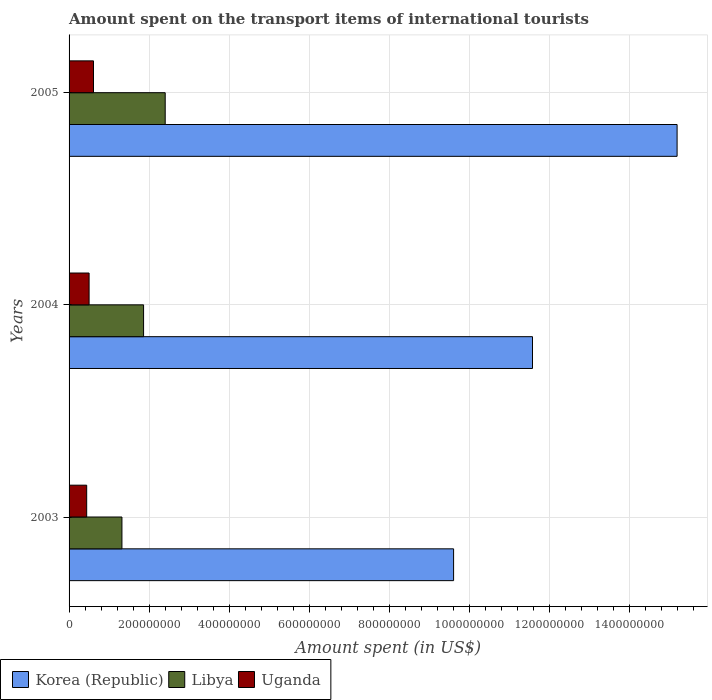How many different coloured bars are there?
Offer a terse response. 3. How many groups of bars are there?
Make the answer very short. 3. Are the number of bars per tick equal to the number of legend labels?
Give a very brief answer. Yes. In how many cases, is the number of bars for a given year not equal to the number of legend labels?
Offer a terse response. 0. Across all years, what is the maximum amount spent on the transport items of international tourists in Libya?
Offer a terse response. 2.40e+08. Across all years, what is the minimum amount spent on the transport items of international tourists in Uganda?
Make the answer very short. 4.40e+07. In which year was the amount spent on the transport items of international tourists in Uganda maximum?
Provide a succinct answer. 2005. In which year was the amount spent on the transport items of international tourists in Libya minimum?
Ensure brevity in your answer.  2003. What is the total amount spent on the transport items of international tourists in Korea (Republic) in the graph?
Your response must be concise. 3.64e+09. What is the difference between the amount spent on the transport items of international tourists in Korea (Republic) in 2003 and that in 2004?
Provide a short and direct response. -1.97e+08. What is the difference between the amount spent on the transport items of international tourists in Libya in 2004 and the amount spent on the transport items of international tourists in Uganda in 2003?
Offer a very short reply. 1.42e+08. What is the average amount spent on the transport items of international tourists in Libya per year?
Make the answer very short. 1.86e+08. In the year 2003, what is the difference between the amount spent on the transport items of international tourists in Libya and amount spent on the transport items of international tourists in Uganda?
Your response must be concise. 8.80e+07. What is the ratio of the amount spent on the transport items of international tourists in Uganda in 2004 to that in 2005?
Ensure brevity in your answer.  0.82. What is the difference between the highest and the second highest amount spent on the transport items of international tourists in Uganda?
Your response must be concise. 1.10e+07. What is the difference between the highest and the lowest amount spent on the transport items of international tourists in Uganda?
Make the answer very short. 1.70e+07. Is the sum of the amount spent on the transport items of international tourists in Korea (Republic) in 2003 and 2004 greater than the maximum amount spent on the transport items of international tourists in Libya across all years?
Give a very brief answer. Yes. What does the 1st bar from the top in 2003 represents?
Your answer should be very brief. Uganda. Is it the case that in every year, the sum of the amount spent on the transport items of international tourists in Uganda and amount spent on the transport items of international tourists in Libya is greater than the amount spent on the transport items of international tourists in Korea (Republic)?
Offer a terse response. No. Does the graph contain grids?
Offer a terse response. Yes. Where does the legend appear in the graph?
Offer a terse response. Bottom left. How many legend labels are there?
Offer a terse response. 3. How are the legend labels stacked?
Make the answer very short. Horizontal. What is the title of the graph?
Your response must be concise. Amount spent on the transport items of international tourists. What is the label or title of the X-axis?
Provide a succinct answer. Amount spent (in US$). What is the label or title of the Y-axis?
Your response must be concise. Years. What is the Amount spent (in US$) in Korea (Republic) in 2003?
Give a very brief answer. 9.60e+08. What is the Amount spent (in US$) in Libya in 2003?
Keep it short and to the point. 1.32e+08. What is the Amount spent (in US$) in Uganda in 2003?
Your answer should be very brief. 4.40e+07. What is the Amount spent (in US$) of Korea (Republic) in 2004?
Give a very brief answer. 1.16e+09. What is the Amount spent (in US$) of Libya in 2004?
Ensure brevity in your answer.  1.86e+08. What is the Amount spent (in US$) of Uganda in 2004?
Offer a terse response. 5.00e+07. What is the Amount spent (in US$) of Korea (Republic) in 2005?
Offer a very short reply. 1.52e+09. What is the Amount spent (in US$) of Libya in 2005?
Your response must be concise. 2.40e+08. What is the Amount spent (in US$) in Uganda in 2005?
Your answer should be compact. 6.10e+07. Across all years, what is the maximum Amount spent (in US$) in Korea (Republic)?
Provide a short and direct response. 1.52e+09. Across all years, what is the maximum Amount spent (in US$) in Libya?
Provide a succinct answer. 2.40e+08. Across all years, what is the maximum Amount spent (in US$) in Uganda?
Provide a succinct answer. 6.10e+07. Across all years, what is the minimum Amount spent (in US$) of Korea (Republic)?
Your answer should be compact. 9.60e+08. Across all years, what is the minimum Amount spent (in US$) of Libya?
Keep it short and to the point. 1.32e+08. Across all years, what is the minimum Amount spent (in US$) in Uganda?
Ensure brevity in your answer.  4.40e+07. What is the total Amount spent (in US$) of Korea (Republic) in the graph?
Make the answer very short. 3.64e+09. What is the total Amount spent (in US$) of Libya in the graph?
Provide a succinct answer. 5.58e+08. What is the total Amount spent (in US$) in Uganda in the graph?
Offer a very short reply. 1.55e+08. What is the difference between the Amount spent (in US$) of Korea (Republic) in 2003 and that in 2004?
Your answer should be very brief. -1.97e+08. What is the difference between the Amount spent (in US$) of Libya in 2003 and that in 2004?
Give a very brief answer. -5.40e+07. What is the difference between the Amount spent (in US$) in Uganda in 2003 and that in 2004?
Offer a terse response. -6.00e+06. What is the difference between the Amount spent (in US$) of Korea (Republic) in 2003 and that in 2005?
Provide a short and direct response. -5.58e+08. What is the difference between the Amount spent (in US$) of Libya in 2003 and that in 2005?
Offer a very short reply. -1.08e+08. What is the difference between the Amount spent (in US$) in Uganda in 2003 and that in 2005?
Give a very brief answer. -1.70e+07. What is the difference between the Amount spent (in US$) in Korea (Republic) in 2004 and that in 2005?
Your answer should be very brief. -3.61e+08. What is the difference between the Amount spent (in US$) in Libya in 2004 and that in 2005?
Your answer should be compact. -5.40e+07. What is the difference between the Amount spent (in US$) of Uganda in 2004 and that in 2005?
Offer a very short reply. -1.10e+07. What is the difference between the Amount spent (in US$) in Korea (Republic) in 2003 and the Amount spent (in US$) in Libya in 2004?
Your response must be concise. 7.74e+08. What is the difference between the Amount spent (in US$) of Korea (Republic) in 2003 and the Amount spent (in US$) of Uganda in 2004?
Make the answer very short. 9.10e+08. What is the difference between the Amount spent (in US$) in Libya in 2003 and the Amount spent (in US$) in Uganda in 2004?
Your answer should be compact. 8.20e+07. What is the difference between the Amount spent (in US$) of Korea (Republic) in 2003 and the Amount spent (in US$) of Libya in 2005?
Offer a very short reply. 7.20e+08. What is the difference between the Amount spent (in US$) of Korea (Republic) in 2003 and the Amount spent (in US$) of Uganda in 2005?
Keep it short and to the point. 8.99e+08. What is the difference between the Amount spent (in US$) in Libya in 2003 and the Amount spent (in US$) in Uganda in 2005?
Your response must be concise. 7.10e+07. What is the difference between the Amount spent (in US$) of Korea (Republic) in 2004 and the Amount spent (in US$) of Libya in 2005?
Your response must be concise. 9.17e+08. What is the difference between the Amount spent (in US$) of Korea (Republic) in 2004 and the Amount spent (in US$) of Uganda in 2005?
Your answer should be compact. 1.10e+09. What is the difference between the Amount spent (in US$) of Libya in 2004 and the Amount spent (in US$) of Uganda in 2005?
Your answer should be very brief. 1.25e+08. What is the average Amount spent (in US$) in Korea (Republic) per year?
Provide a succinct answer. 1.21e+09. What is the average Amount spent (in US$) of Libya per year?
Your answer should be very brief. 1.86e+08. What is the average Amount spent (in US$) of Uganda per year?
Your answer should be very brief. 5.17e+07. In the year 2003, what is the difference between the Amount spent (in US$) of Korea (Republic) and Amount spent (in US$) of Libya?
Offer a terse response. 8.28e+08. In the year 2003, what is the difference between the Amount spent (in US$) in Korea (Republic) and Amount spent (in US$) in Uganda?
Your answer should be compact. 9.16e+08. In the year 2003, what is the difference between the Amount spent (in US$) in Libya and Amount spent (in US$) in Uganda?
Your answer should be very brief. 8.80e+07. In the year 2004, what is the difference between the Amount spent (in US$) in Korea (Republic) and Amount spent (in US$) in Libya?
Provide a short and direct response. 9.71e+08. In the year 2004, what is the difference between the Amount spent (in US$) of Korea (Republic) and Amount spent (in US$) of Uganda?
Your response must be concise. 1.11e+09. In the year 2004, what is the difference between the Amount spent (in US$) in Libya and Amount spent (in US$) in Uganda?
Provide a short and direct response. 1.36e+08. In the year 2005, what is the difference between the Amount spent (in US$) in Korea (Republic) and Amount spent (in US$) in Libya?
Keep it short and to the point. 1.28e+09. In the year 2005, what is the difference between the Amount spent (in US$) in Korea (Republic) and Amount spent (in US$) in Uganda?
Your answer should be very brief. 1.46e+09. In the year 2005, what is the difference between the Amount spent (in US$) of Libya and Amount spent (in US$) of Uganda?
Your answer should be compact. 1.79e+08. What is the ratio of the Amount spent (in US$) in Korea (Republic) in 2003 to that in 2004?
Offer a terse response. 0.83. What is the ratio of the Amount spent (in US$) in Libya in 2003 to that in 2004?
Your response must be concise. 0.71. What is the ratio of the Amount spent (in US$) in Korea (Republic) in 2003 to that in 2005?
Your answer should be very brief. 0.63. What is the ratio of the Amount spent (in US$) in Libya in 2003 to that in 2005?
Give a very brief answer. 0.55. What is the ratio of the Amount spent (in US$) of Uganda in 2003 to that in 2005?
Ensure brevity in your answer.  0.72. What is the ratio of the Amount spent (in US$) in Korea (Republic) in 2004 to that in 2005?
Provide a short and direct response. 0.76. What is the ratio of the Amount spent (in US$) of Libya in 2004 to that in 2005?
Keep it short and to the point. 0.78. What is the ratio of the Amount spent (in US$) of Uganda in 2004 to that in 2005?
Ensure brevity in your answer.  0.82. What is the difference between the highest and the second highest Amount spent (in US$) of Korea (Republic)?
Ensure brevity in your answer.  3.61e+08. What is the difference between the highest and the second highest Amount spent (in US$) of Libya?
Your answer should be very brief. 5.40e+07. What is the difference between the highest and the second highest Amount spent (in US$) of Uganda?
Your answer should be very brief. 1.10e+07. What is the difference between the highest and the lowest Amount spent (in US$) in Korea (Republic)?
Your answer should be compact. 5.58e+08. What is the difference between the highest and the lowest Amount spent (in US$) of Libya?
Provide a succinct answer. 1.08e+08. What is the difference between the highest and the lowest Amount spent (in US$) of Uganda?
Provide a succinct answer. 1.70e+07. 